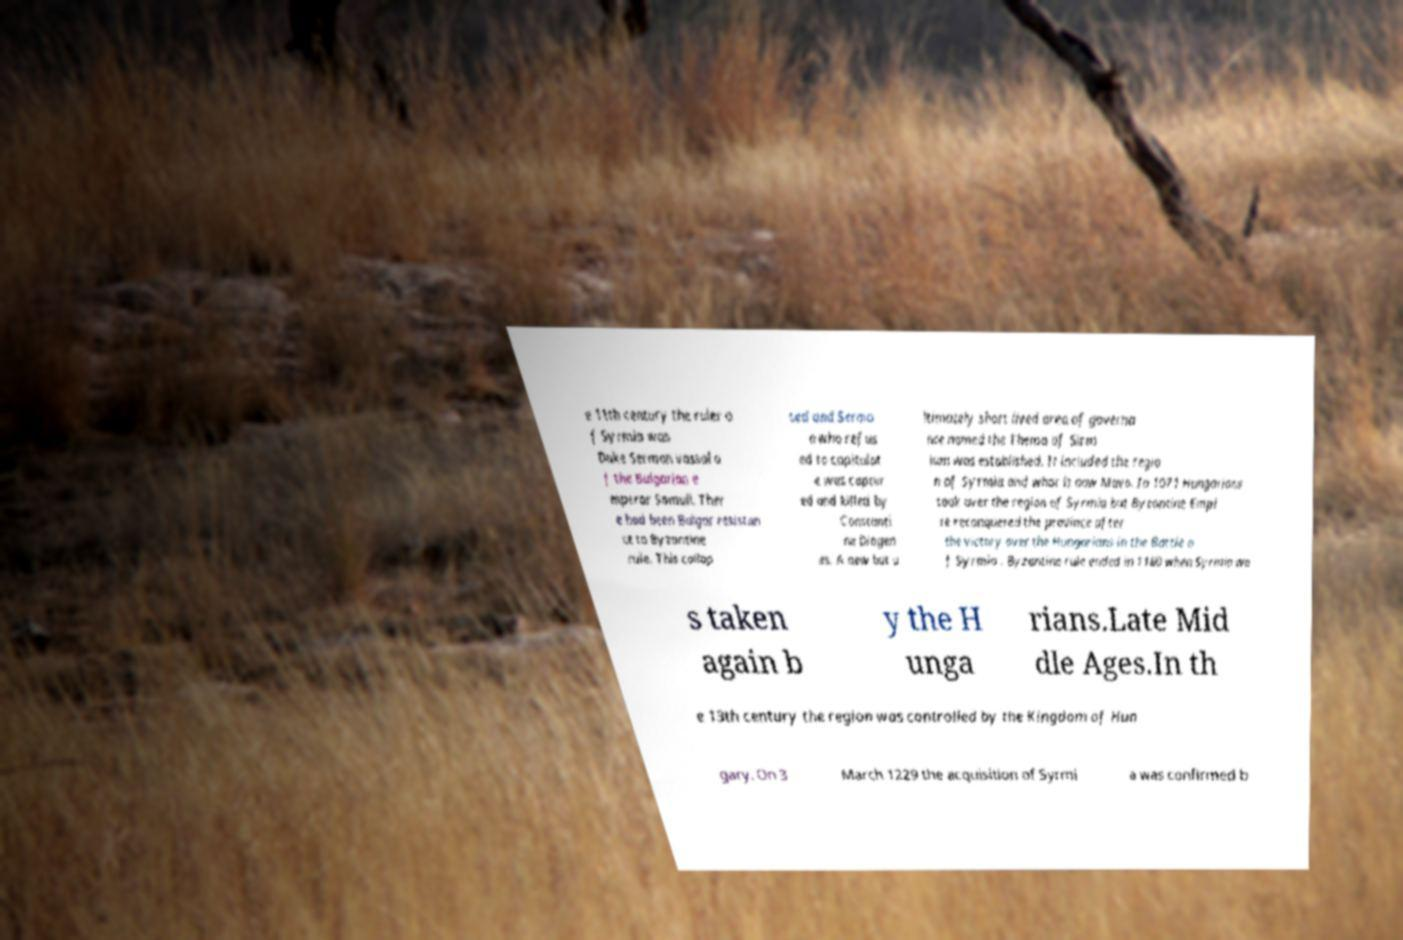What messages or text are displayed in this image? I need them in a readable, typed format. e 11th century the ruler o f Syrmia was Duke Sermon vassal o f the Bulgarian e mperor Samuil. Ther e had been Bulgar resistan ce to Byzantine rule. This collap sed and Sermo n who refus ed to capitulat e was captur ed and killed by Constanti ne Diogen es. A new but u ltimately short lived area of governa nce named the Thema of Sirm ium was established. It included the regio n of Syrmia and what is now Mava. In 1071 Hungarians took over the region of Syrmia but Byzantine Empi re reconquered the province after the victory over the Hungarians in the Battle o f Syrmia . Byzantine rule ended in 1180 when Syrmia wa s taken again b y the H unga rians.Late Mid dle Ages.In th e 13th century the region was controlled by the Kingdom of Hun gary. On 3 March 1229 the acquisition of Syrmi a was confirmed b 